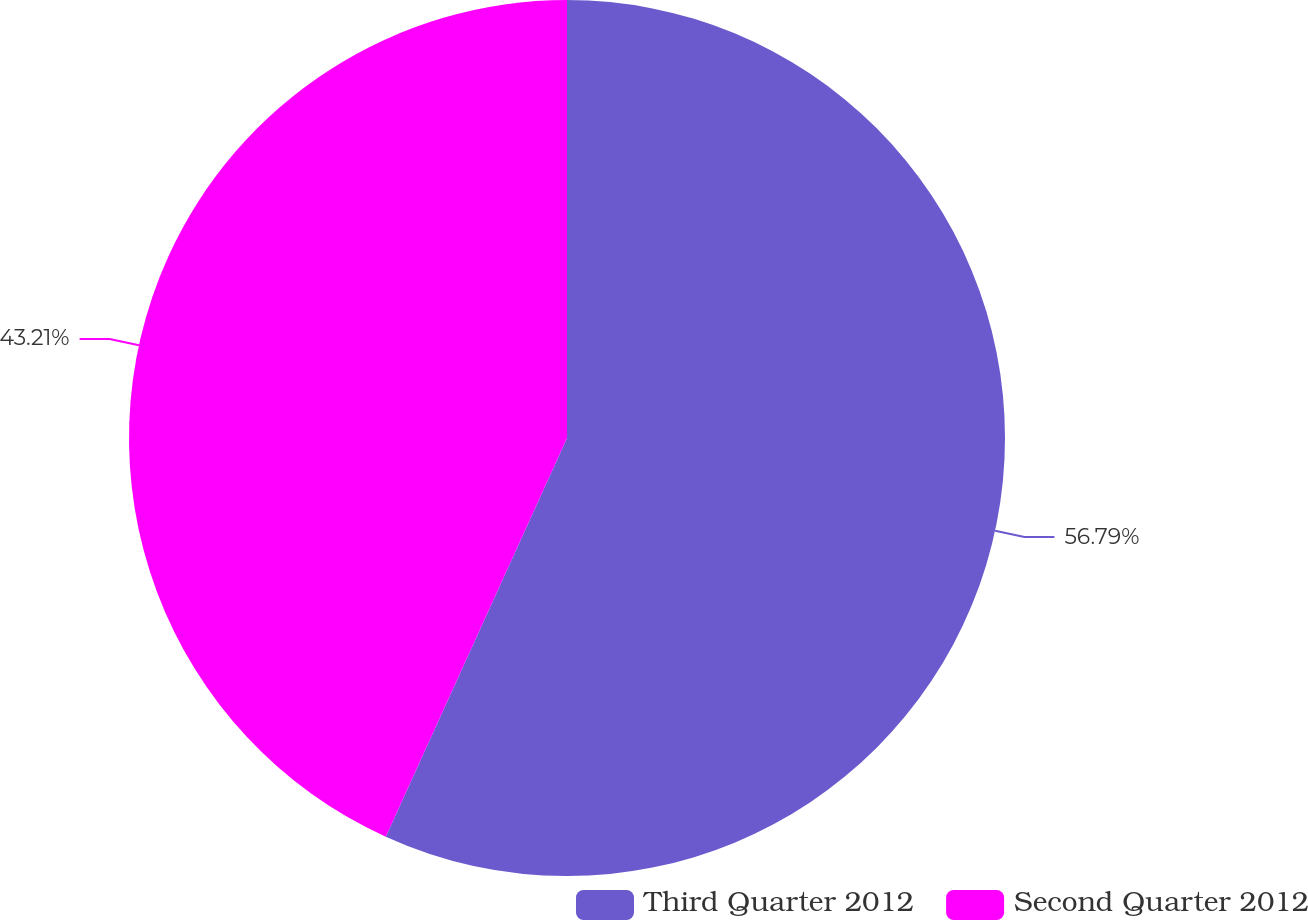Convert chart to OTSL. <chart><loc_0><loc_0><loc_500><loc_500><pie_chart><fcel>Third Quarter 2012<fcel>Second Quarter 2012<nl><fcel>56.79%<fcel>43.21%<nl></chart> 